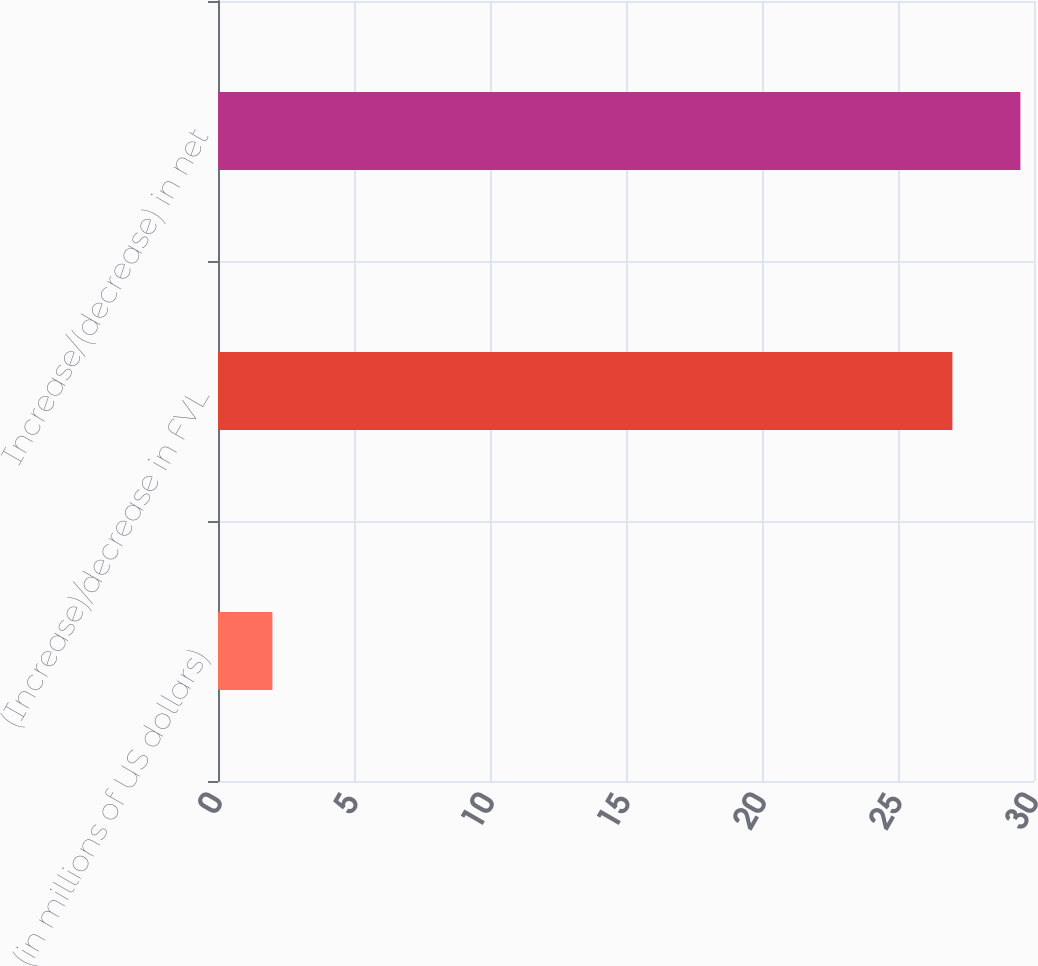Convert chart to OTSL. <chart><loc_0><loc_0><loc_500><loc_500><bar_chart><fcel>(in millions of US dollars)<fcel>(Increase)/decrease in FVL<fcel>Increase/(decrease) in net<nl><fcel>2<fcel>27<fcel>29.5<nl></chart> 